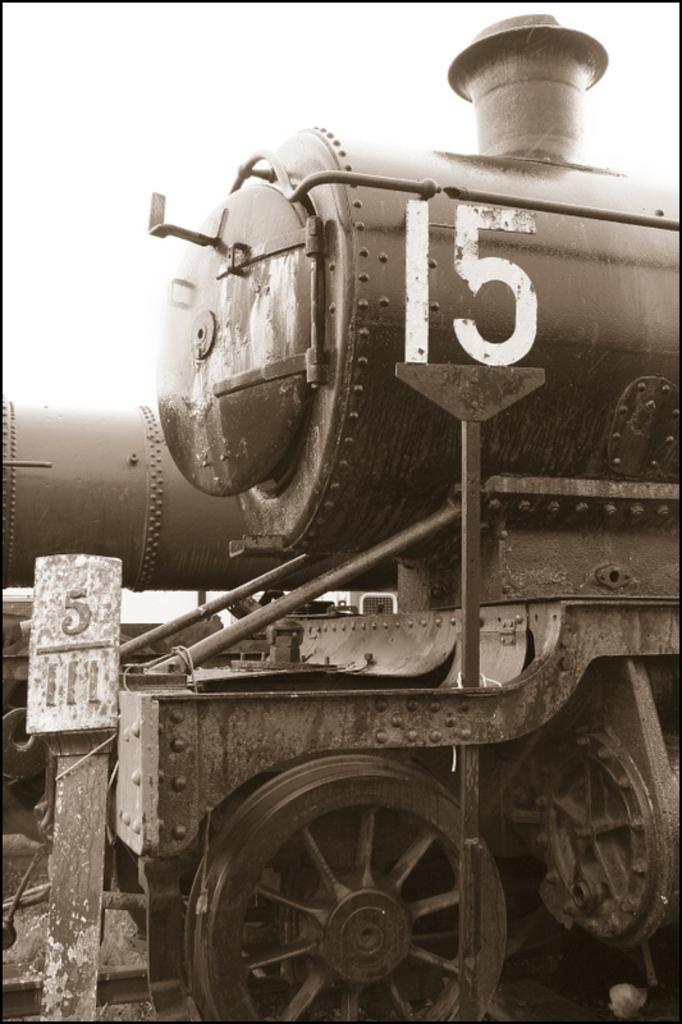In one or two sentences, can you explain what this image depicts? In the picture we can see a rail engine with a smoke exhaust and wheels of it and near to it we can see a board on it with a number 5/111. 